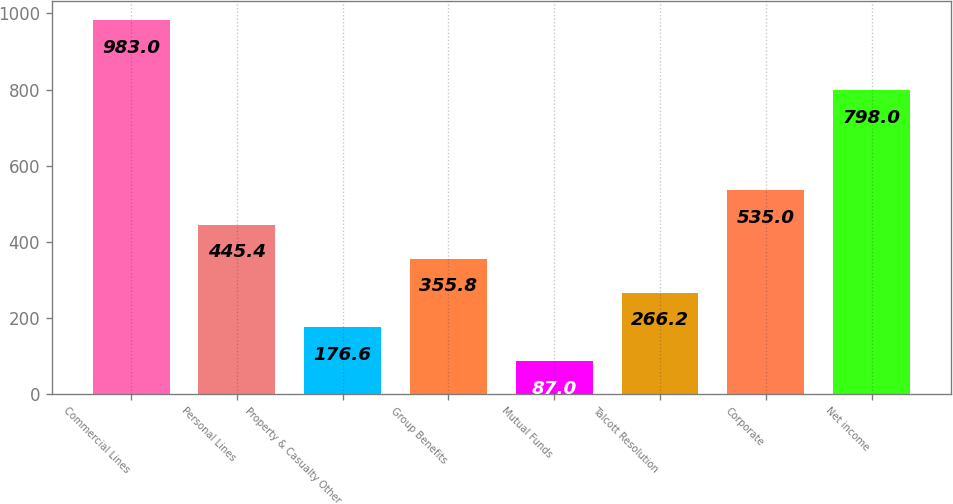Convert chart to OTSL. <chart><loc_0><loc_0><loc_500><loc_500><bar_chart><fcel>Commercial Lines<fcel>Personal Lines<fcel>Property & Casualty Other<fcel>Group Benefits<fcel>Mutual Funds<fcel>Talcott Resolution<fcel>Corporate<fcel>Net income<nl><fcel>983<fcel>445.4<fcel>176.6<fcel>355.8<fcel>87<fcel>266.2<fcel>535<fcel>798<nl></chart> 